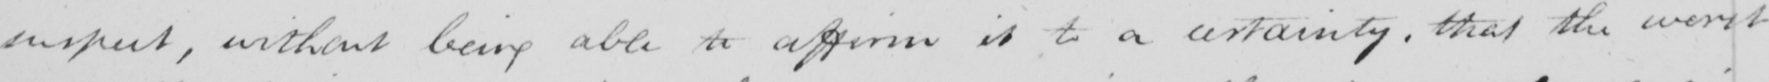What does this handwritten line say? suspect , without being able to affirm it to a certainty , that the worst 